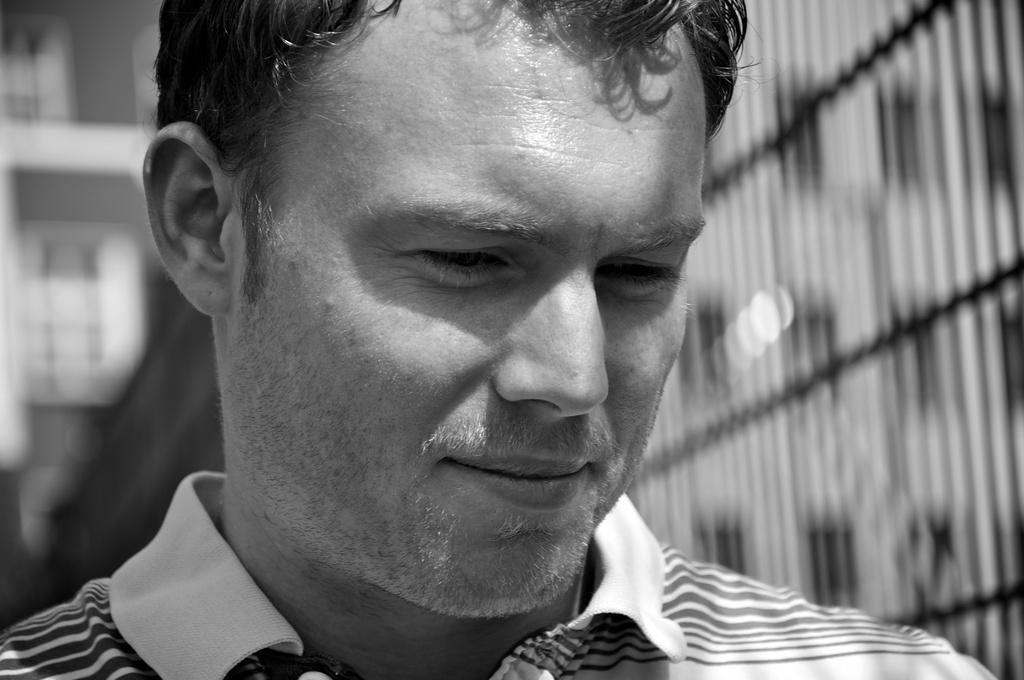What is the main subject of the picture? The main subject of the picture is a man. Can you describe the man's position in the image? The man is standing in the front. What is the man's facial expression in the image? The man is smiling. What is the man looking at in the image? The man is looking down. How would you describe the background of the image? The background is blurred. Can you identify any specific objects in the background? Yes, there is an iron fencing grill in the background. Can you see any visible veins on the man's hands in the image? There is no information about the man's hands or veins in the image, so it cannot be determined. What type of connection is the man making with the clover in the image? There is no clover present in the image, so it is not possible to answer that question. 